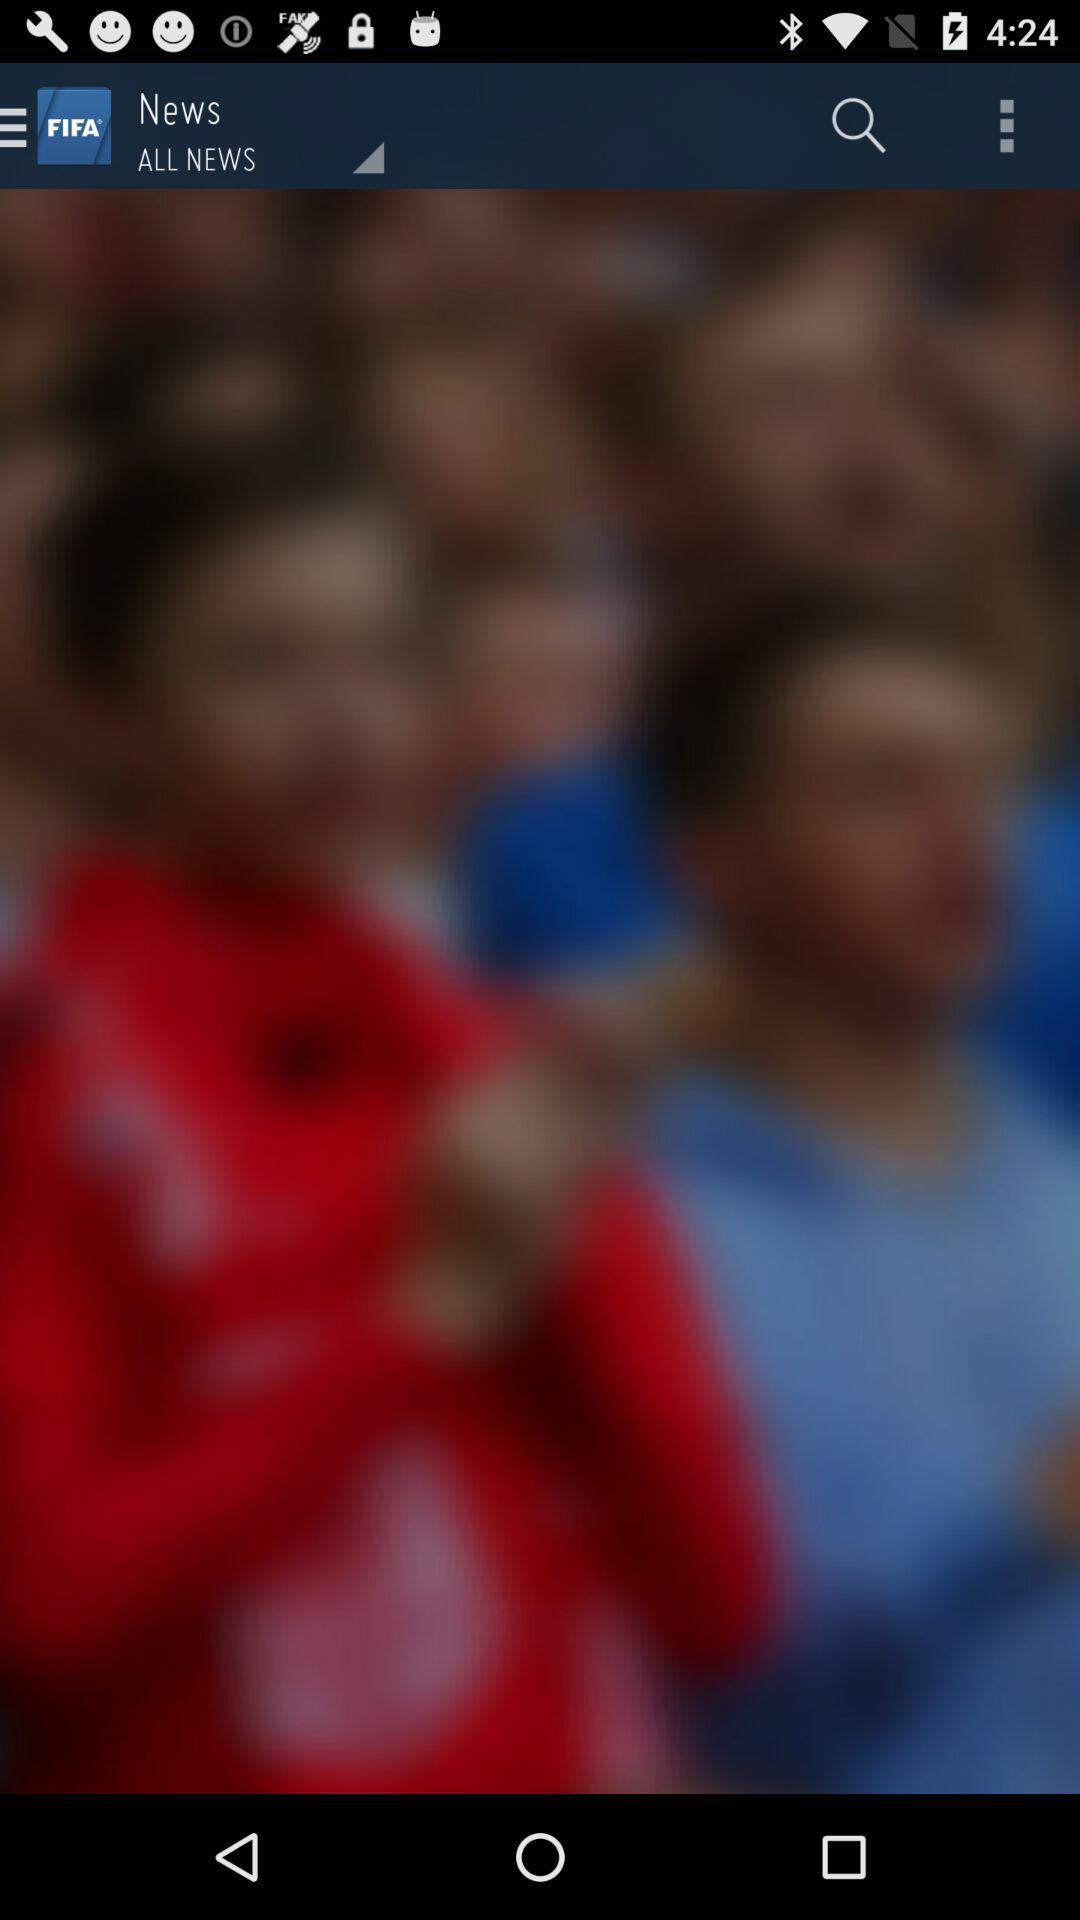What is the application name? The application name is "FIFA". 